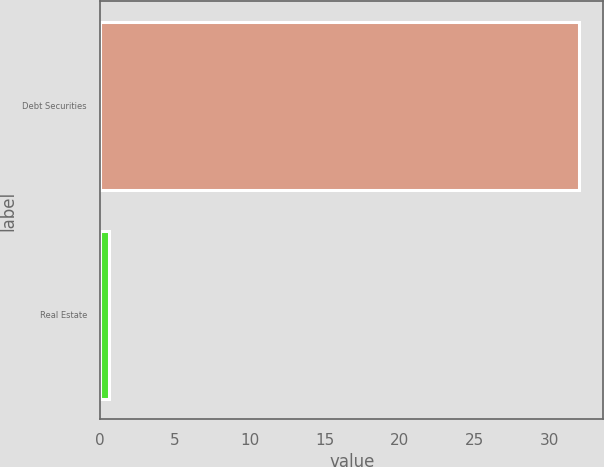<chart> <loc_0><loc_0><loc_500><loc_500><bar_chart><fcel>Debt Securities<fcel>Real Estate<nl><fcel>32<fcel>0.56<nl></chart> 